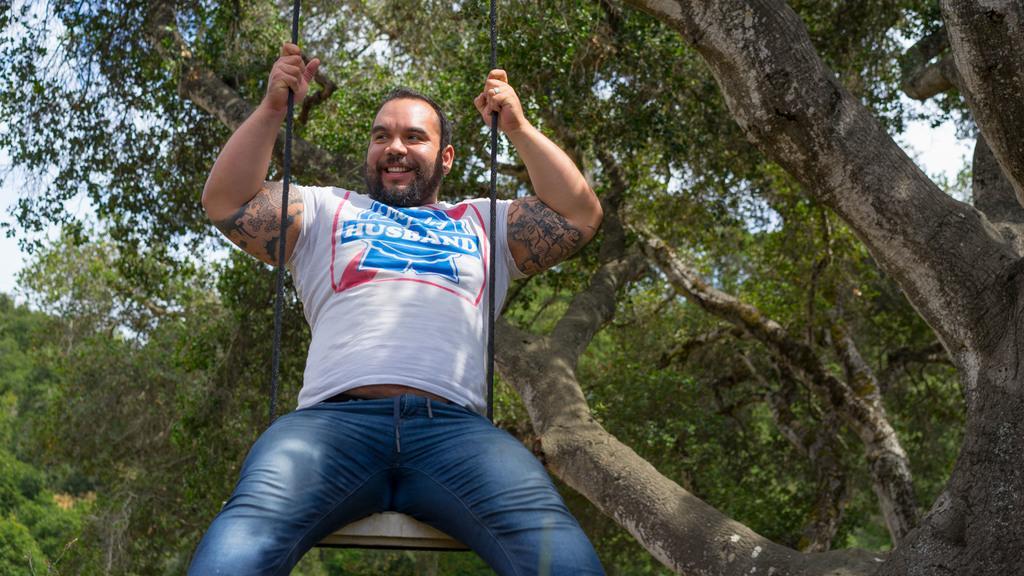Describe this image in one or two sentences. In the image we can see there is a person sitting on the swing and behind there are trees. 